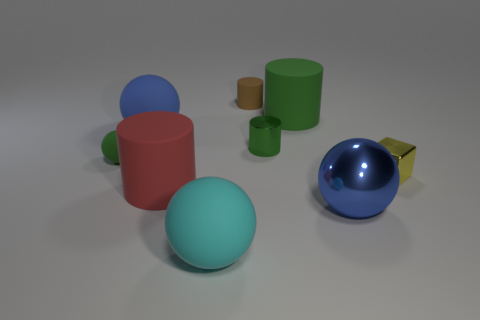Subtract all spheres. How many objects are left? 5 Add 7 gray cylinders. How many gray cylinders exist? 7 Subtract 0 cyan cylinders. How many objects are left? 9 Subtract all small brown matte things. Subtract all large objects. How many objects are left? 3 Add 7 small brown rubber objects. How many small brown rubber objects are left? 8 